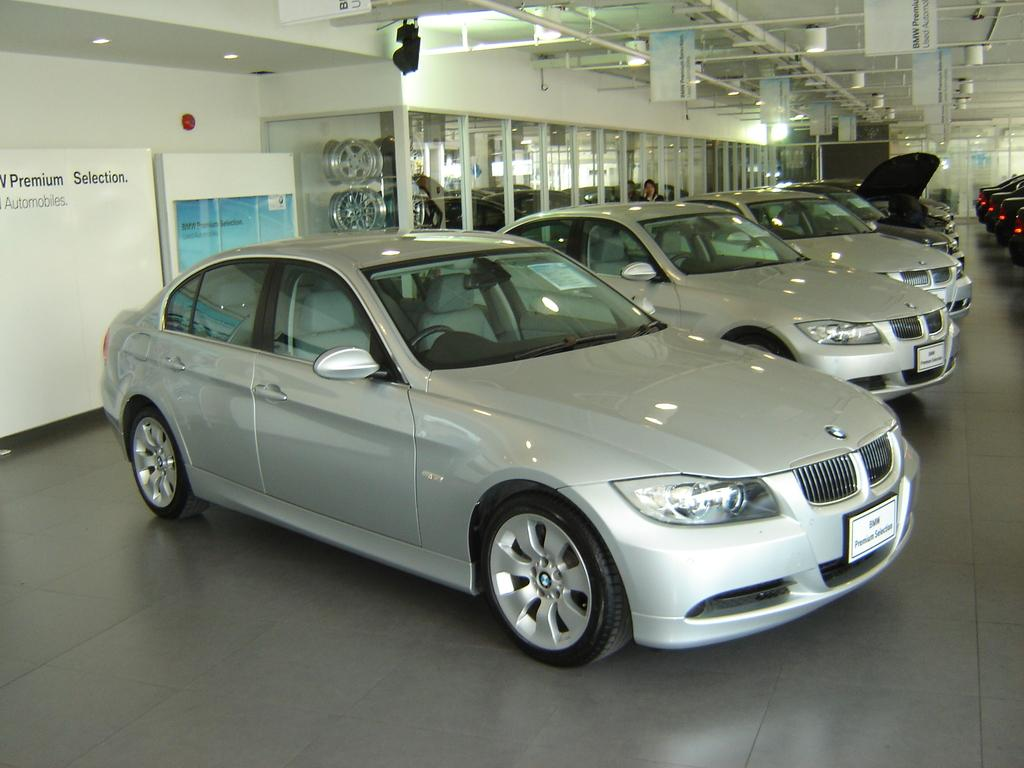What objects are on the floor in the image? There are cars on the floor in the image. What type of objects can be seen in the image besides the cars? There are boards, a wall, wheels, and a person visible in the image. What material is present in the image that is transparent? There is glass visible in the image. Where are the boards located in the image? At the top of the image, there are boards. What can be found at the top of the image along with the boards? At the top of the image, there are lights. What color is the acoustics in the image? There is no mention of acoustics in the image, as it is a visual medium. The image does not have a color associated with acoustics. 